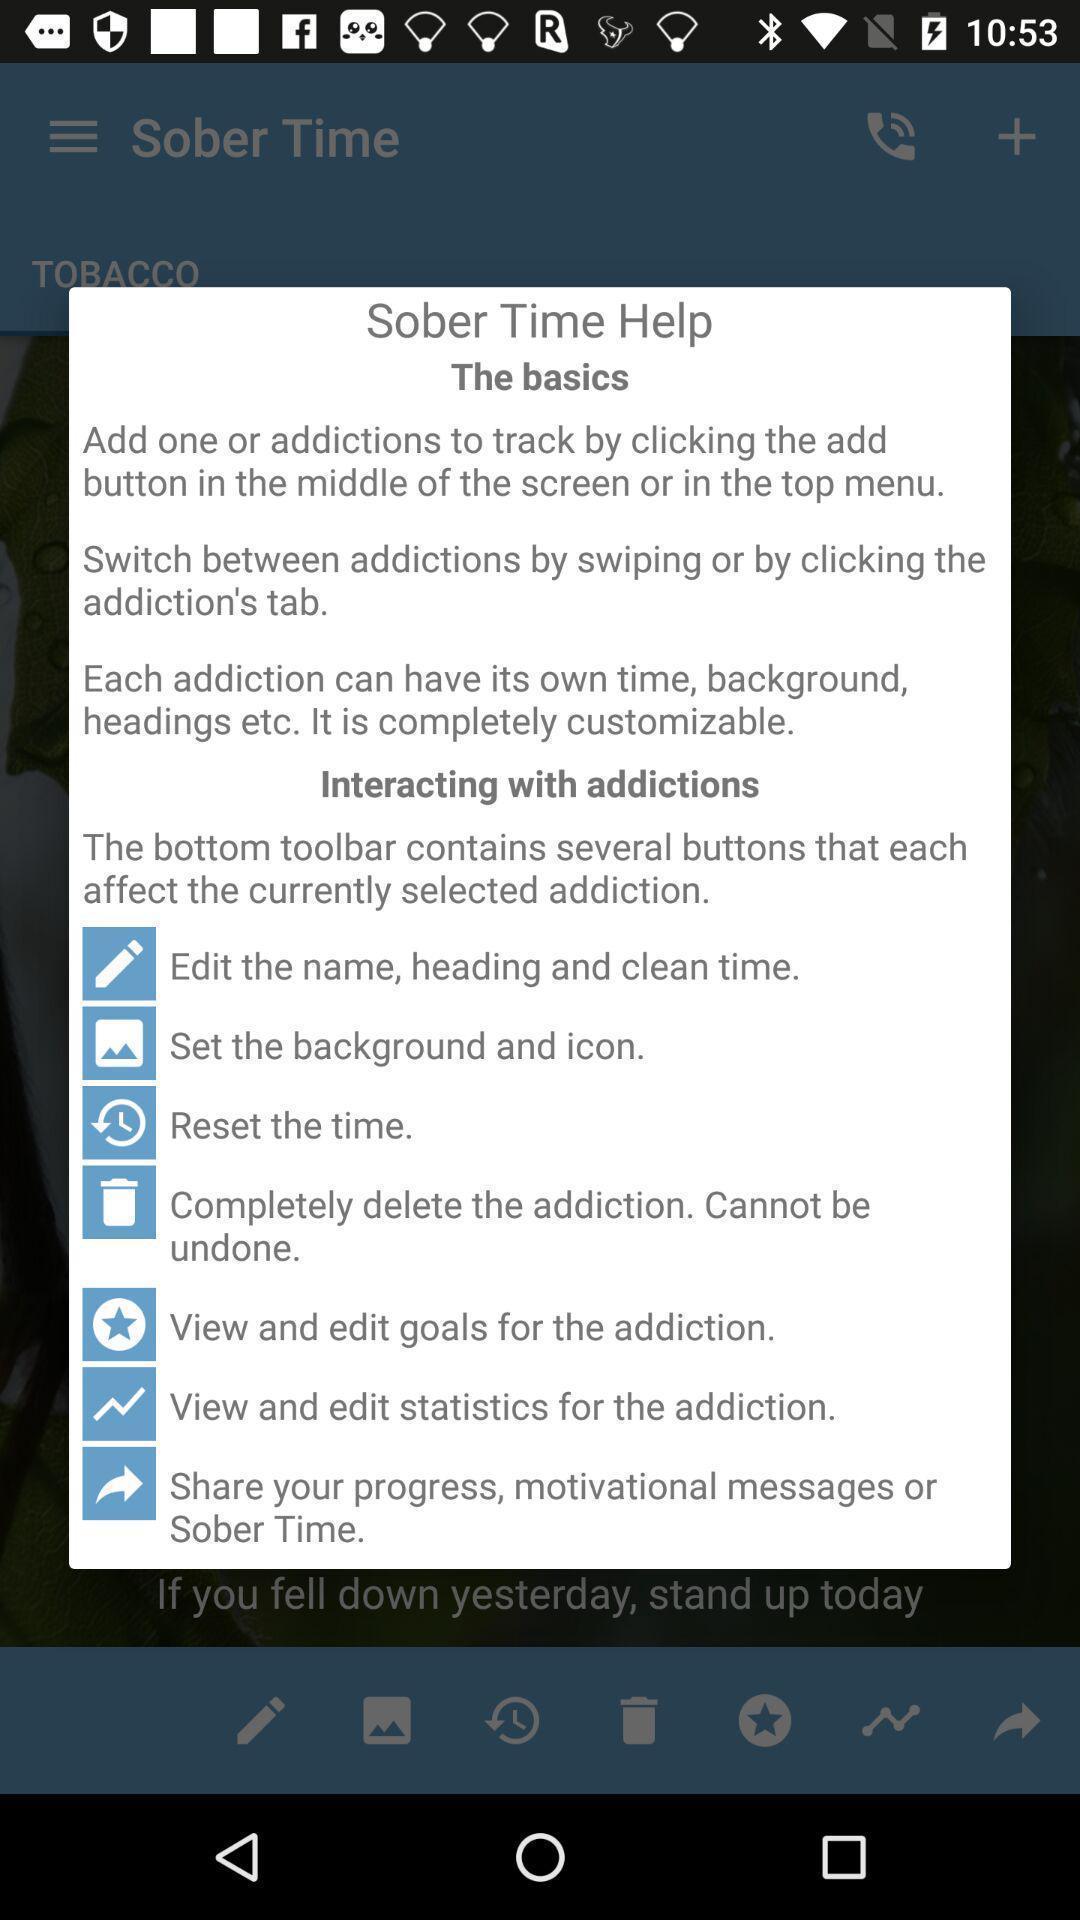What can you discern from this picture? Pop-up displaying information about different controls. 